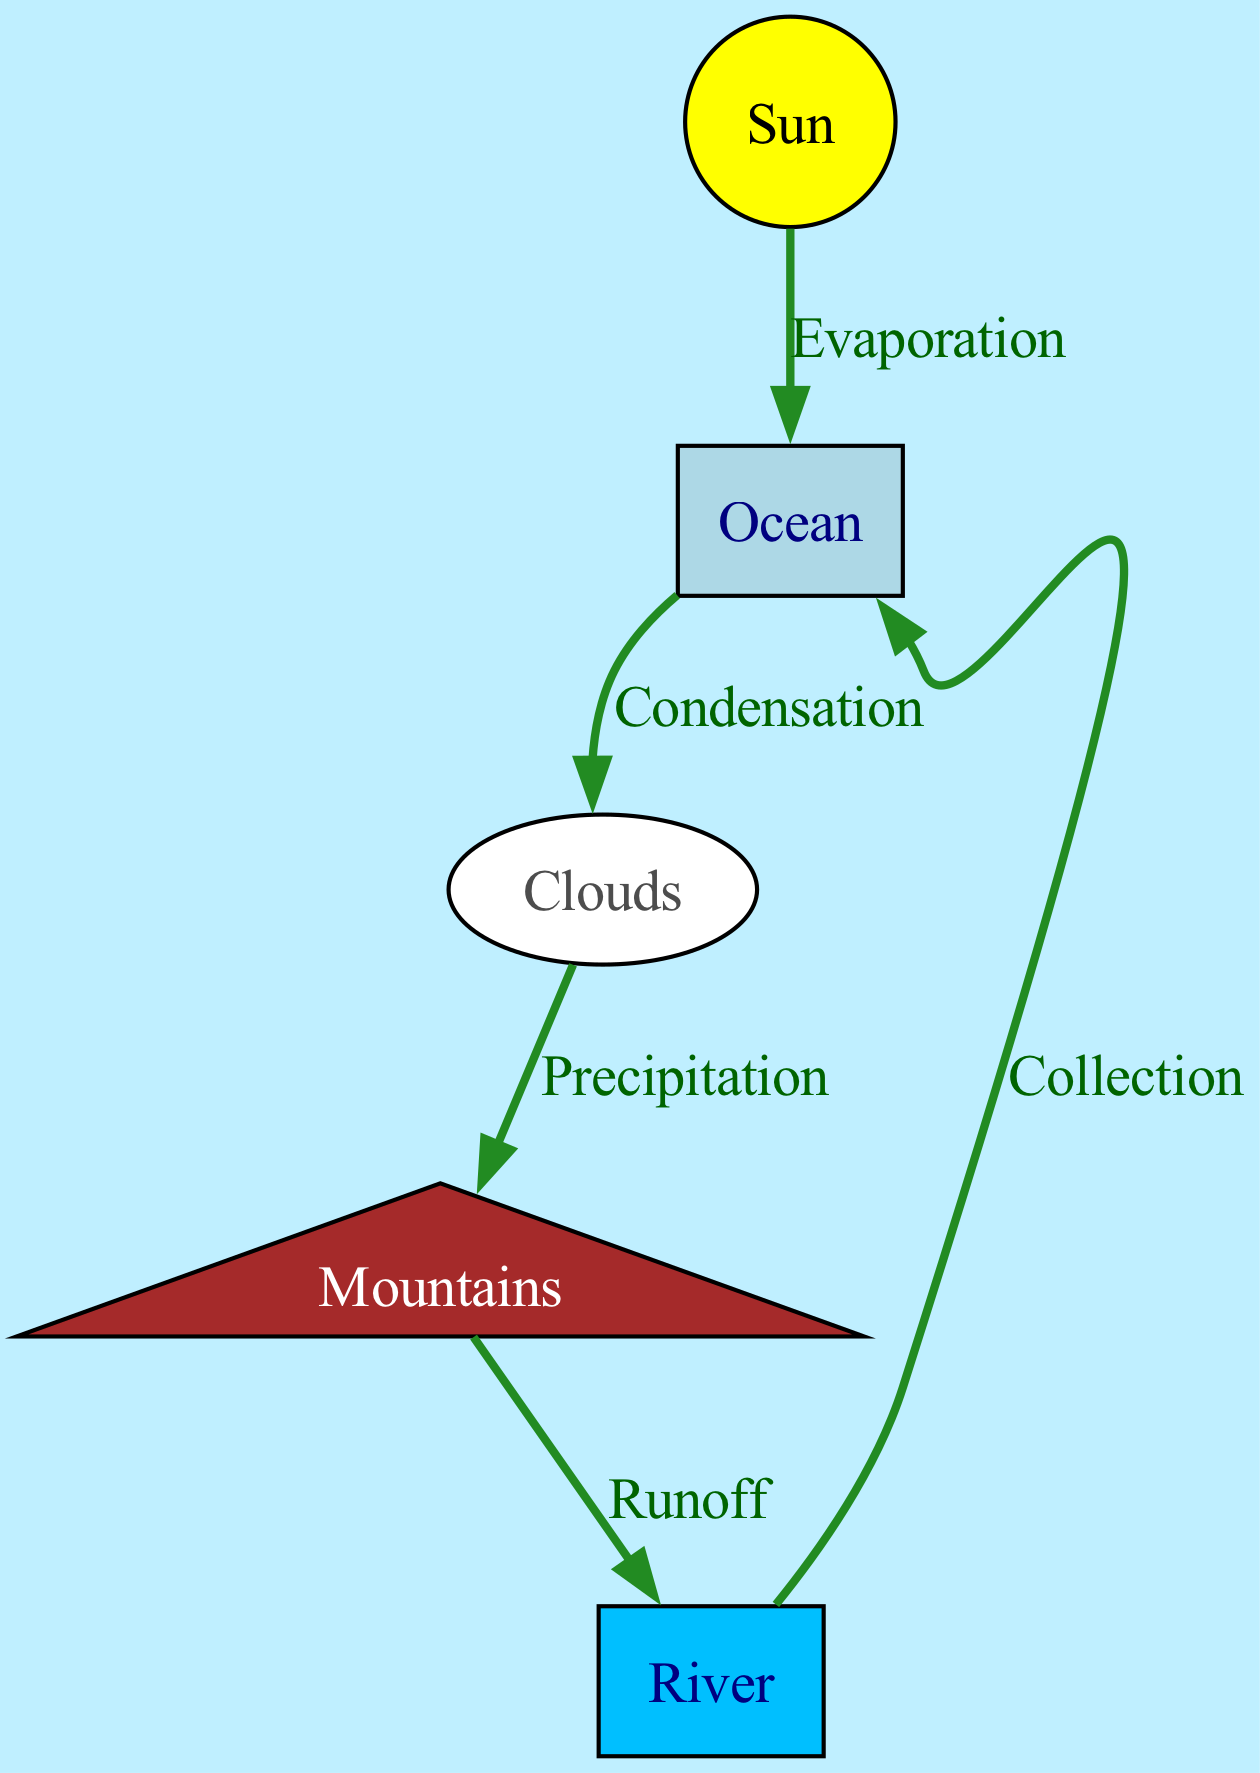What are the processes shown in the edges? The edges represent the four main processes of the water cycle: Evaporation, Condensation, Precipitation, and Runoff. Each edge connects different nodes and labels these processes clearly.
Answer: Evaporation, Condensation, Precipitation, Runoff How many nodes are in the diagram? There are five nodes labeled Sun, Ocean, Clouds, Mountains, and River that represent different components in the water cycle diagram.
Answer: 5 What is the direction of water movement from Clouds to Mountains? The edge labeled 'Precipitation' indicates that from the Clouds, water moves downward to the Mountains due to gravity, which represents rainfall or snowfall.
Answer: Downward Which node is connected to both Ocean and Clouds? The edge labeled 'Evaporation' shows the connection from the Ocean to Clouds, indicating that water vapor moves from the Ocean to the Clouds through evaporation.
Answer: Ocean What type of landforms do the Mountains represent? The Mountains are described as elevated landforms, which indicates that they are higher in altitude compared to other elements depicted in the cycle.
Answer: Elevated landforms Which process leads to water returning to the Ocean? The edge labeled 'Collection' from the River back to the Ocean indicates that this process shows how water returns to the Ocean, completing the water cycle.
Answer: Collection Which edge represents the transformation of water from vapor into droplets? The edge labeled 'Condensation' describes how water vapor changes into liquid droplets, leading to cloud formation in the cycle.
Answer: Condensation Which node is the primary source of energy in the water cycle? The Sun node is labeled as the energy source, indicating its role in driving processes like evaporation within the water cycle.
Answer: Sun 